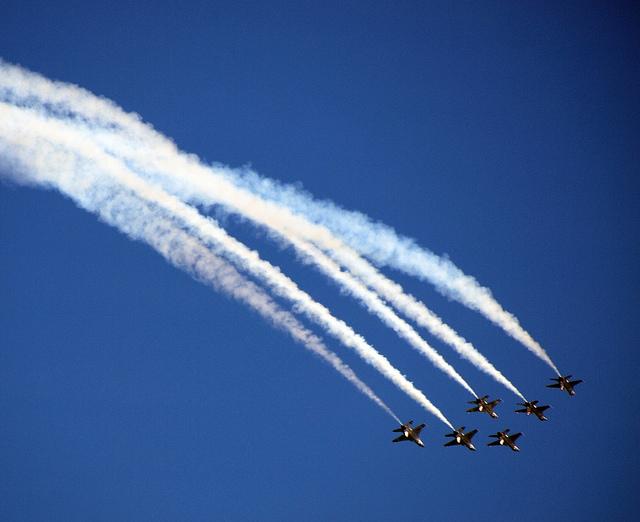Are these planes flying in a specific formation?
Keep it brief. Yes. How many planes?
Concise answer only. 6. What color is the sky?
Short answer required. Blue. 